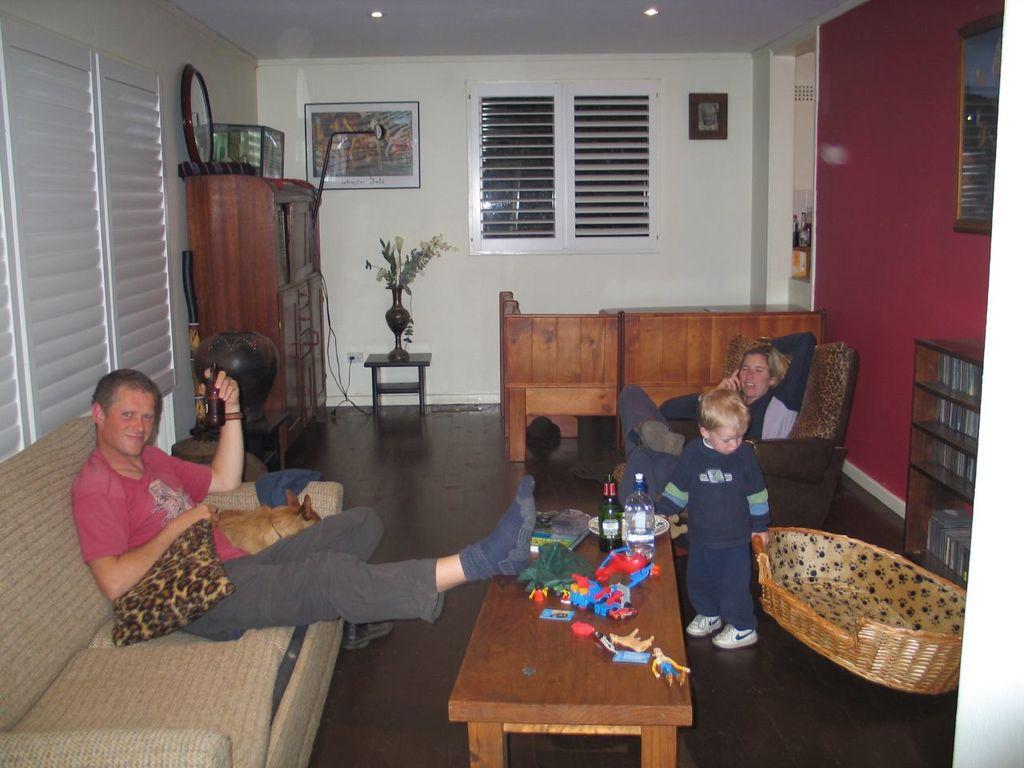Could you give a brief overview of what you see in this image? The image is taken inside the room. In the center of the image there is a table. There are toys, bottles, books placed on the table. On the left side there is a man and a dog sitting on the sofa behind him there is a cup board. There is a stand and a decor which is placed on the stand. On the right there is a kid who is holding a basket behind him there is a lady sitting on the cushion. In the background there is a window, wall frame and a wall. 